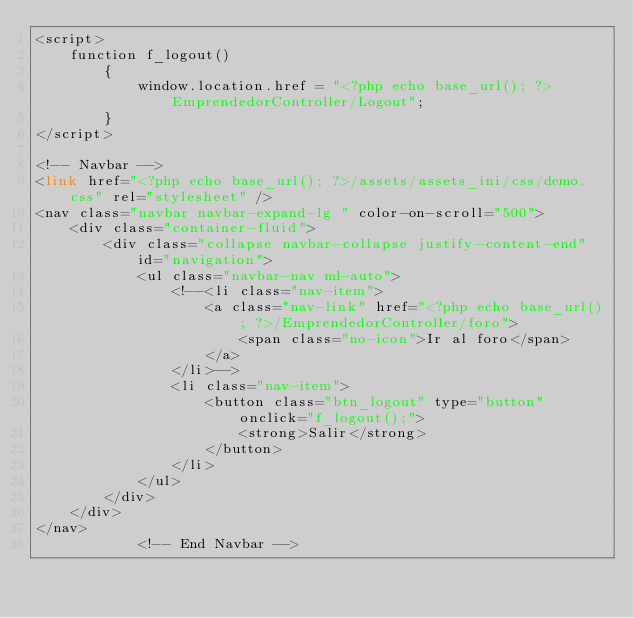<code> <loc_0><loc_0><loc_500><loc_500><_PHP_><script>
    function f_logout()
        {
            window.location.href = "<?php echo base_url(); ?>EmprendedorController/Logout";
        }
</script>

<!-- Navbar -->
<link href="<?php echo base_url(); ?>/assets/assets_ini/css/demo.css" rel="stylesheet" />
<nav class="navbar navbar-expand-lg " color-on-scroll="500">
    <div class="container-fluid">
        <div class="collapse navbar-collapse justify-content-end" id="navigation">
            <ul class="navbar-nav ml-auto">
                <!--<li class="nav-item">
                    <a class="nav-link" href="<?php echo base_url(); ?>/EmprendedorController/foro">
                        <span class="no-icon">Ir al foro</span>
                    </a>
                </li>-->
                <li class="nav-item">
                    <button class="btn_logout" type="button" onclick="f_logout();">
                        <strong>Salir</strong>
                    </button>
                </li>
            </ul>
        </div>
    </div>
</nav>
            <!-- End Navbar --></code> 